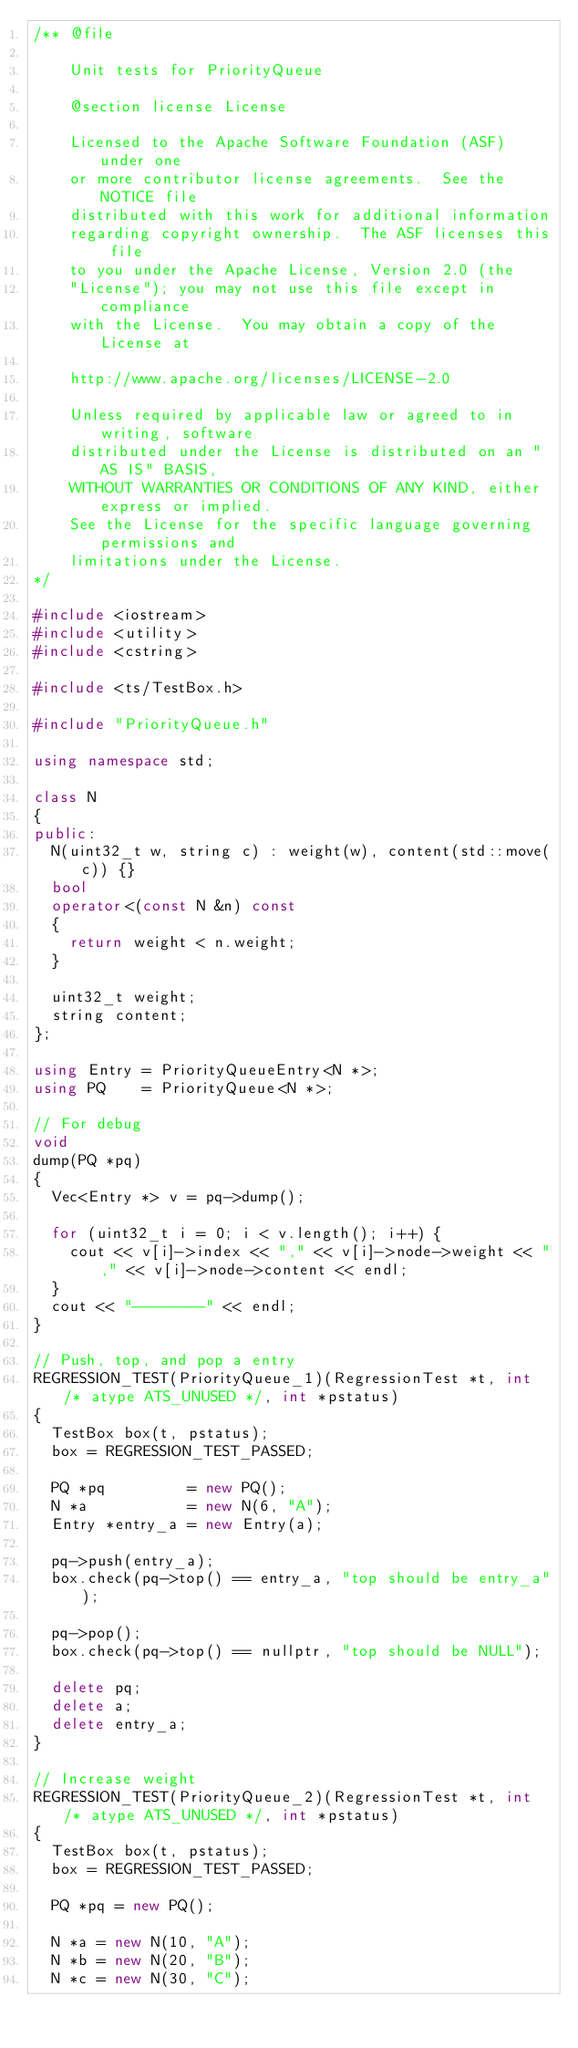Convert code to text. <code><loc_0><loc_0><loc_500><loc_500><_C++_>/** @file

    Unit tests for PriorityQueue

    @section license License

    Licensed to the Apache Software Foundation (ASF) under one
    or more contributor license agreements.  See the NOTICE file
    distributed with this work for additional information
    regarding copyright ownership.  The ASF licenses this file
    to you under the Apache License, Version 2.0 (the
    "License"); you may not use this file except in compliance
    with the License.  You may obtain a copy of the License at

    http://www.apache.org/licenses/LICENSE-2.0

    Unless required by applicable law or agreed to in writing, software
    distributed under the License is distributed on an "AS IS" BASIS,
    WITHOUT WARRANTIES OR CONDITIONS OF ANY KIND, either express or implied.
    See the License for the specific language governing permissions and
    limitations under the License.
*/

#include <iostream>
#include <utility>
#include <cstring>

#include <ts/TestBox.h>

#include "PriorityQueue.h"

using namespace std;

class N
{
public:
  N(uint32_t w, string c) : weight(w), content(std::move(c)) {}
  bool
  operator<(const N &n) const
  {
    return weight < n.weight;
  }

  uint32_t weight;
  string content;
};

using Entry = PriorityQueueEntry<N *>;
using PQ    = PriorityQueue<N *>;

// For debug
void
dump(PQ *pq)
{
  Vec<Entry *> v = pq->dump();

  for (uint32_t i = 0; i < v.length(); i++) {
    cout << v[i]->index << "," << v[i]->node->weight << "," << v[i]->node->content << endl;
  }
  cout << "--------" << endl;
}

// Push, top, and pop a entry
REGRESSION_TEST(PriorityQueue_1)(RegressionTest *t, int /* atype ATS_UNUSED */, int *pstatus)
{
  TestBox box(t, pstatus);
  box = REGRESSION_TEST_PASSED;

  PQ *pq         = new PQ();
  N *a           = new N(6, "A");
  Entry *entry_a = new Entry(a);

  pq->push(entry_a);
  box.check(pq->top() == entry_a, "top should be entry_a");

  pq->pop();
  box.check(pq->top() == nullptr, "top should be NULL");

  delete pq;
  delete a;
  delete entry_a;
}

// Increase weight
REGRESSION_TEST(PriorityQueue_2)(RegressionTest *t, int /* atype ATS_UNUSED */, int *pstatus)
{
  TestBox box(t, pstatus);
  box = REGRESSION_TEST_PASSED;

  PQ *pq = new PQ();

  N *a = new N(10, "A");
  N *b = new N(20, "B");
  N *c = new N(30, "C");
</code> 